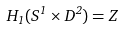<formula> <loc_0><loc_0><loc_500><loc_500>H _ { 1 } ( S ^ { 1 } \times D ^ { 2 } ) = Z</formula> 